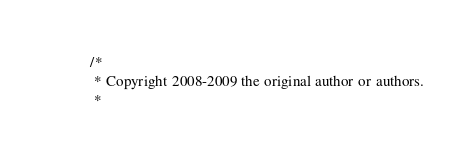Convert code to text. <code><loc_0><loc_0><loc_500><loc_500><_Java_>/*
 * Copyright 2008-2009 the original author or authors.
 *</code> 